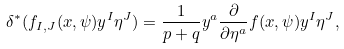<formula> <loc_0><loc_0><loc_500><loc_500>\delta ^ { * } ( f _ { I , J } ( x , \psi ) y ^ { I } \eta ^ { J } ) = \frac { 1 } { p + q } y ^ { a } \frac { \partial } { \partial \eta ^ { a } } f ( x , \psi ) y ^ { I } \eta ^ { J } ,</formula> 